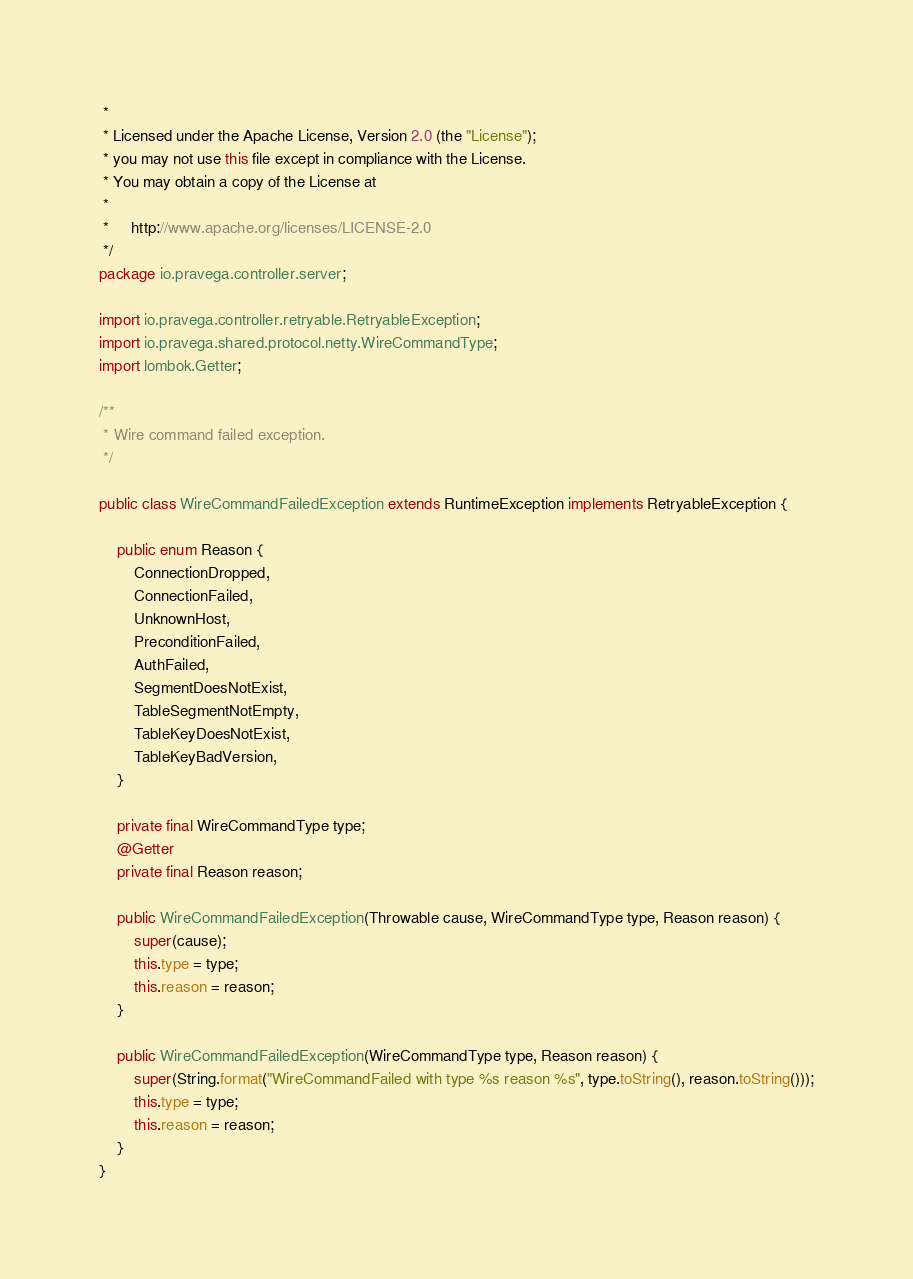Convert code to text. <code><loc_0><loc_0><loc_500><loc_500><_Java_> *
 * Licensed under the Apache License, Version 2.0 (the "License");
 * you may not use this file except in compliance with the License.
 * You may obtain a copy of the License at
 *
 *     http://www.apache.org/licenses/LICENSE-2.0
 */
package io.pravega.controller.server;

import io.pravega.controller.retryable.RetryableException;
import io.pravega.shared.protocol.netty.WireCommandType;
import lombok.Getter;

/**
 * Wire command failed exception.
 */

public class WireCommandFailedException extends RuntimeException implements RetryableException {

    public enum Reason {
        ConnectionDropped,
        ConnectionFailed,
        UnknownHost,
        PreconditionFailed,
        AuthFailed,
        SegmentDoesNotExist,
        TableSegmentNotEmpty,
        TableKeyDoesNotExist,
        TableKeyBadVersion,
    }

    private final WireCommandType type;
    @Getter
    private final Reason reason;

    public WireCommandFailedException(Throwable cause, WireCommandType type, Reason reason) {
        super(cause);
        this.type = type;
        this.reason = reason;
    }

    public WireCommandFailedException(WireCommandType type, Reason reason) {
        super(String.format("WireCommandFailed with type %s reason %s", type.toString(), reason.toString()));
        this.type = type;
        this.reason = reason;
    }
}
</code> 